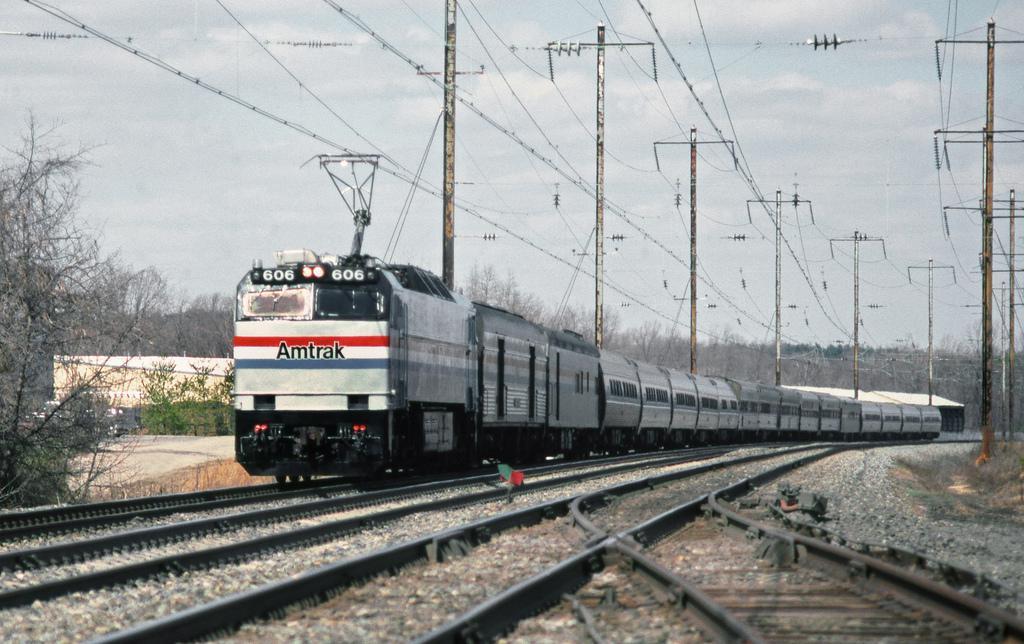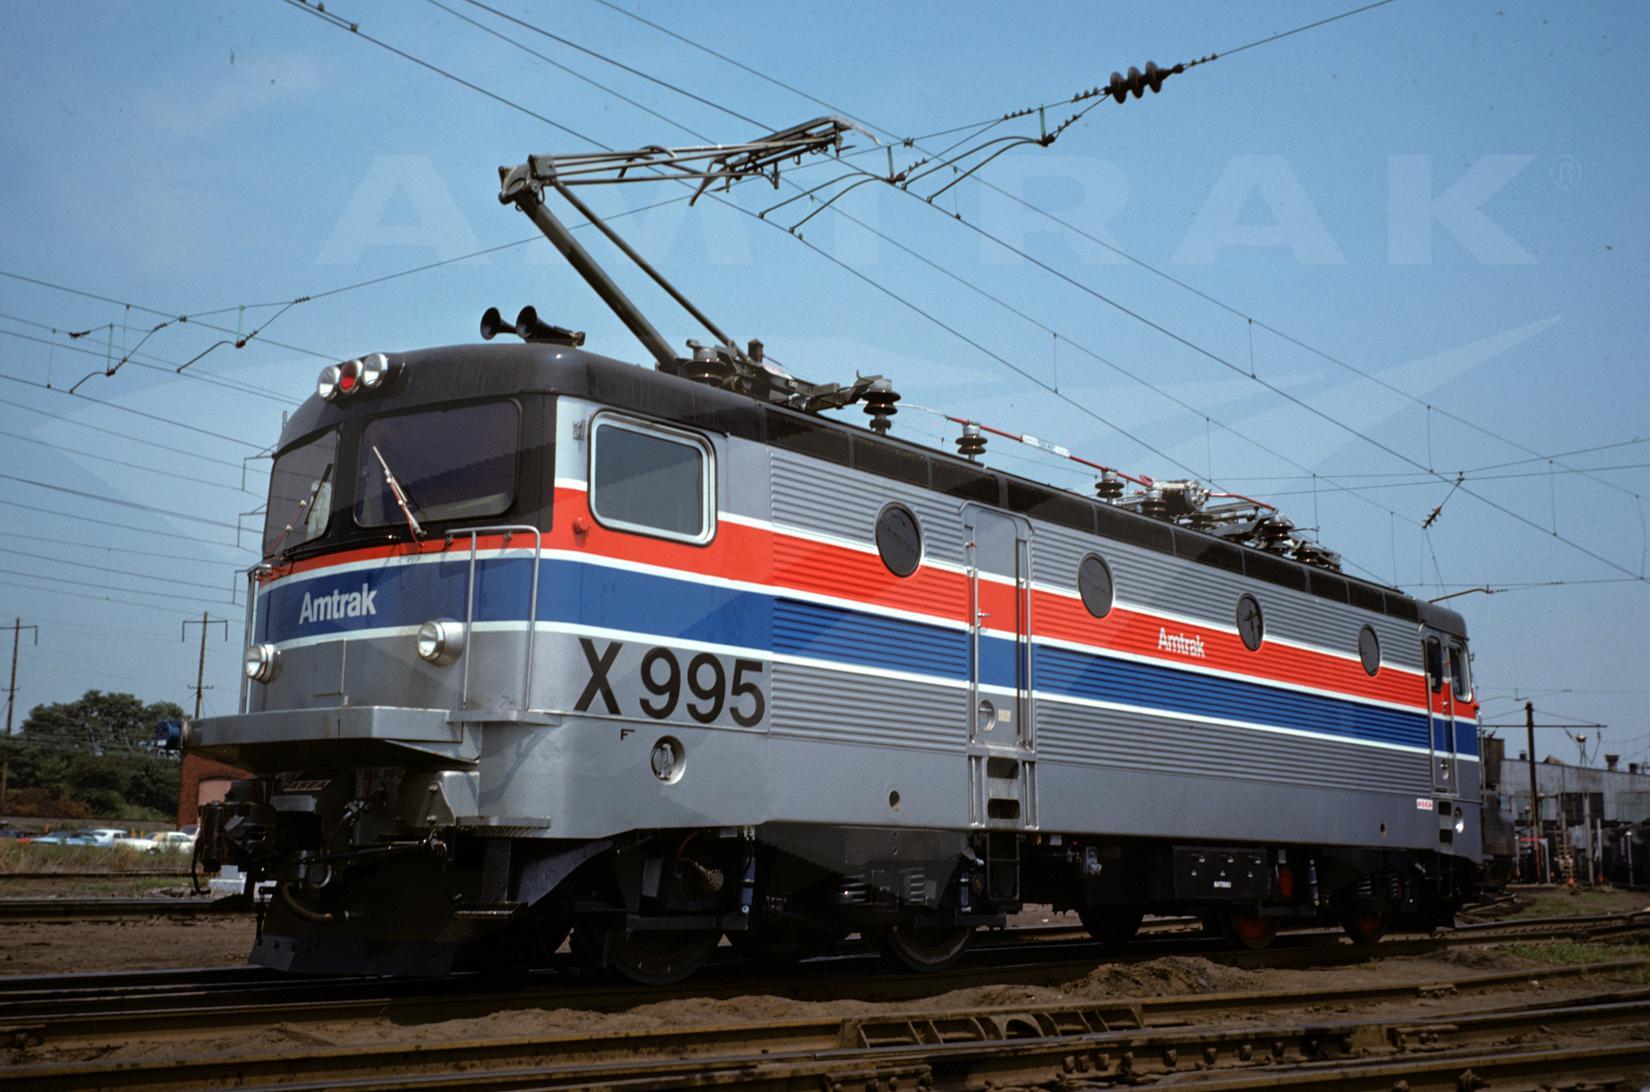The first image is the image on the left, the second image is the image on the right. Assess this claim about the two images: "At least one train has a flat front and blue and red stripes outlined in white running the length of the sides.". Correct or not? Answer yes or no. Yes. 